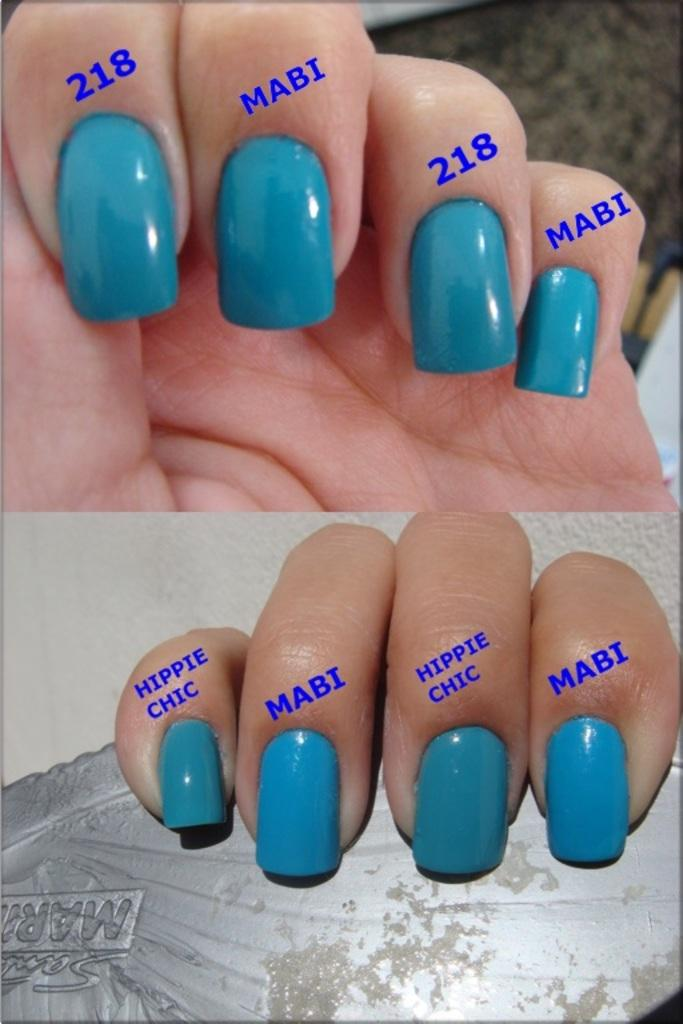<image>
Present a compact description of the photo's key features. Hippie Chic is one way of describing certain fingers. 